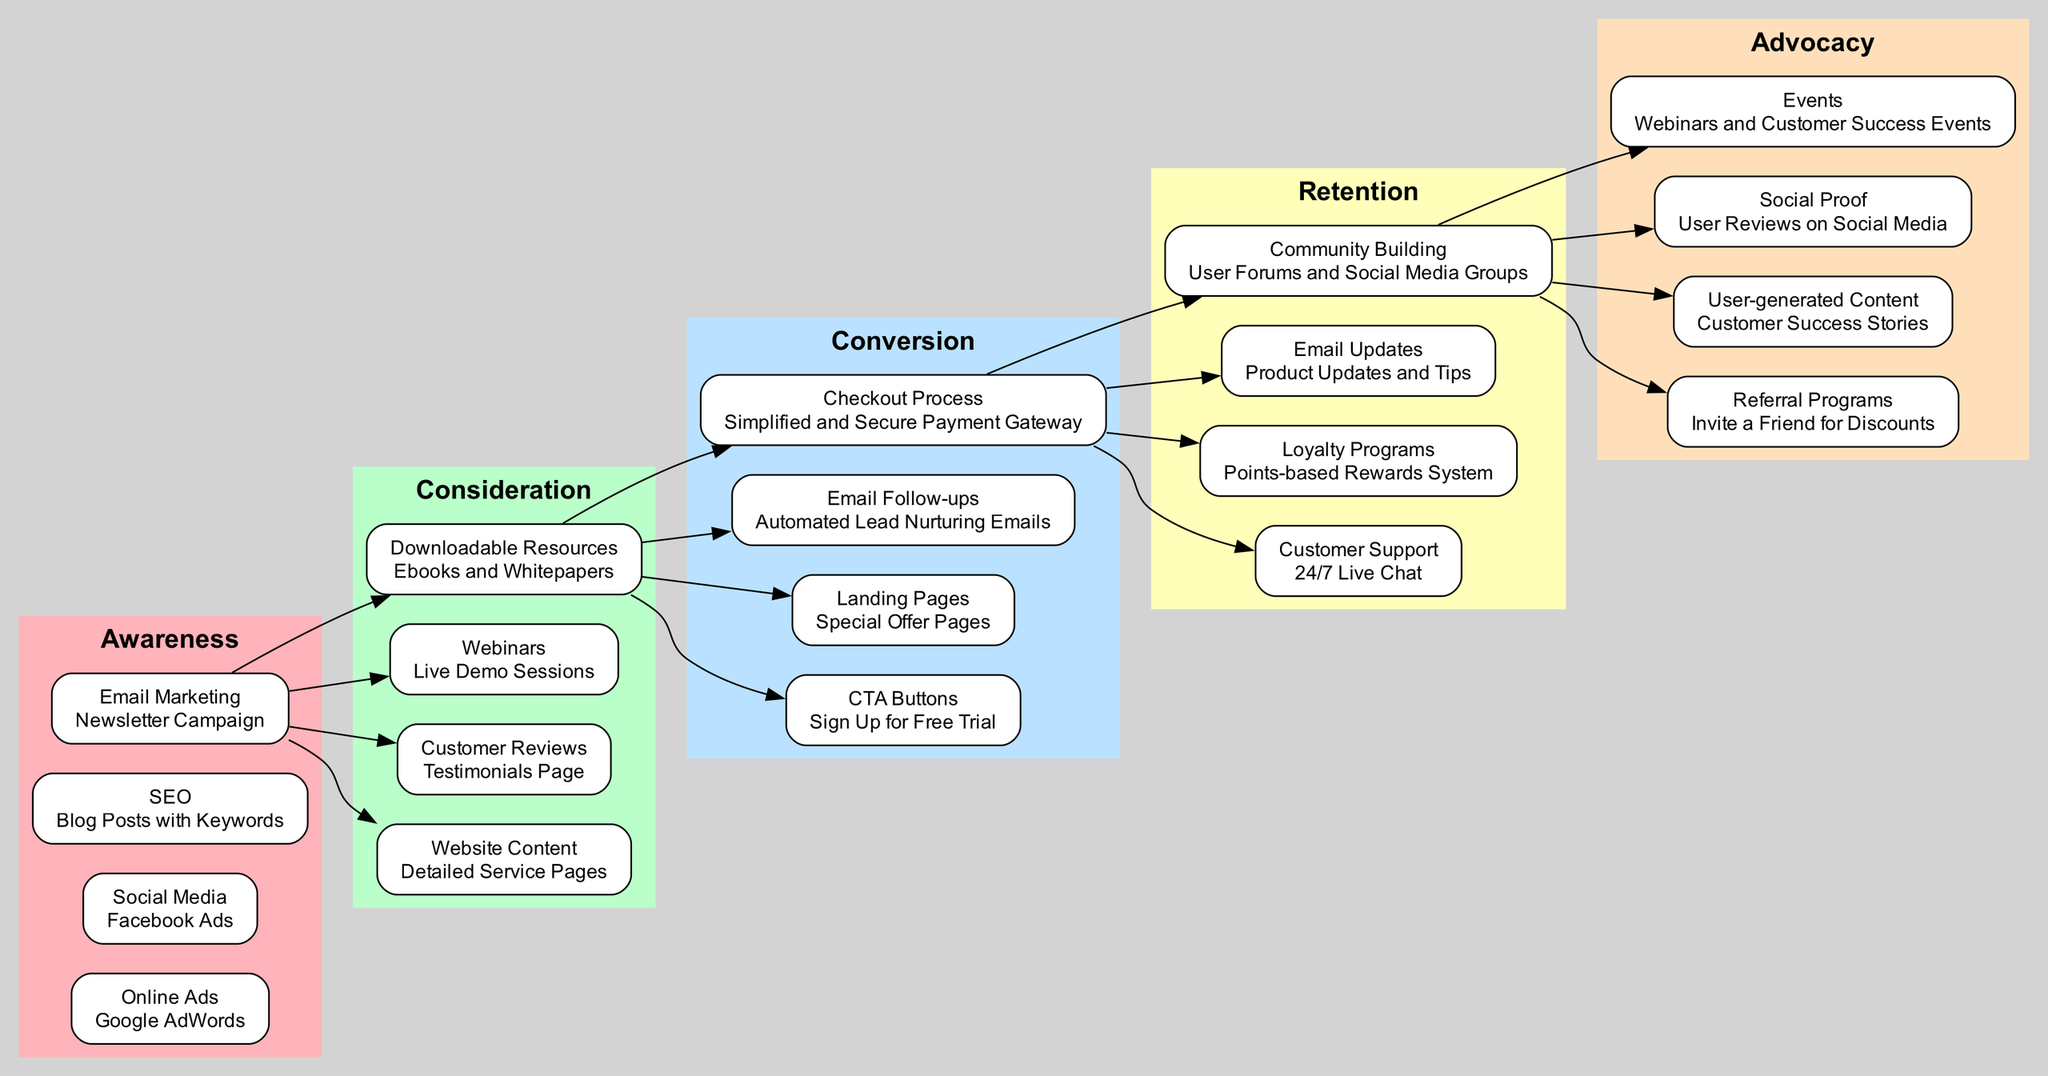What is the first stage in the customer journey? The diagram starts with the "Awareness" stage, which is the initial point of the customer journey flow.
Answer: Awareness Which online advertising method is listed under the Awareness stage? "Google AdWords" appears as the online advertising method in the Awareness stage of the diagram.
Answer: Google AdWords How many actions are listed under the Consideration stage? The Consideration stage includes four actions: Detailed Service Pages, Testimonials Page, Live Demo Sessions, and Ebooks and Whitepapers, totaling four actions.
Answer: 4 What is the main action listed under the Conversion stage? "Sign Up for Free Trial" is the primary action listed under the Conversion stage.
Answer: Sign Up for Free Trial Which customer support option is mentioned in the Retention stage? The Retention stage features "24/7 Live Chat" as a customer support option, indicating constant availability for assistance.
Answer: 24/7 Live Chat What type of programs are included in the Advocacy stage? "Referral Programs" is explicitly mentioned under the Advocacy stage, aimed at encouraging customer referrals.
Answer: Referral Programs How does the Engagement flow from the Awareness to Consideration stage? The flow from Awareness to Consideration progresses as potential customers move from being aware of services through ads and content engagement, leading to deeper consideration through detailed service information and customer reviews.
Answer: Through engagement with ads and content Which two elements are connected from Retention to Advocacy? The flow from Retention leads to Advocacy, connecting "Community Building" and "User-generated Content," showing how loyal customers can generate positive advocacy through community engagement.
Answer: Community Building and User-generated Content What email strategy is applied during Conversion? "Automated Lead Nurturing Emails" are utilized as an email strategy in the Conversion stage to guide potential customers towards making a purchase decision.
Answer: Automated Lead Nurturing Emails 